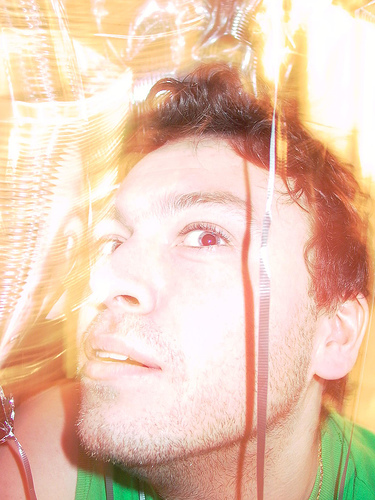<image>
Is there a person on the ribbon? No. The person is not positioned on the ribbon. They may be near each other, but the person is not supported by or resting on top of the ribbon. 